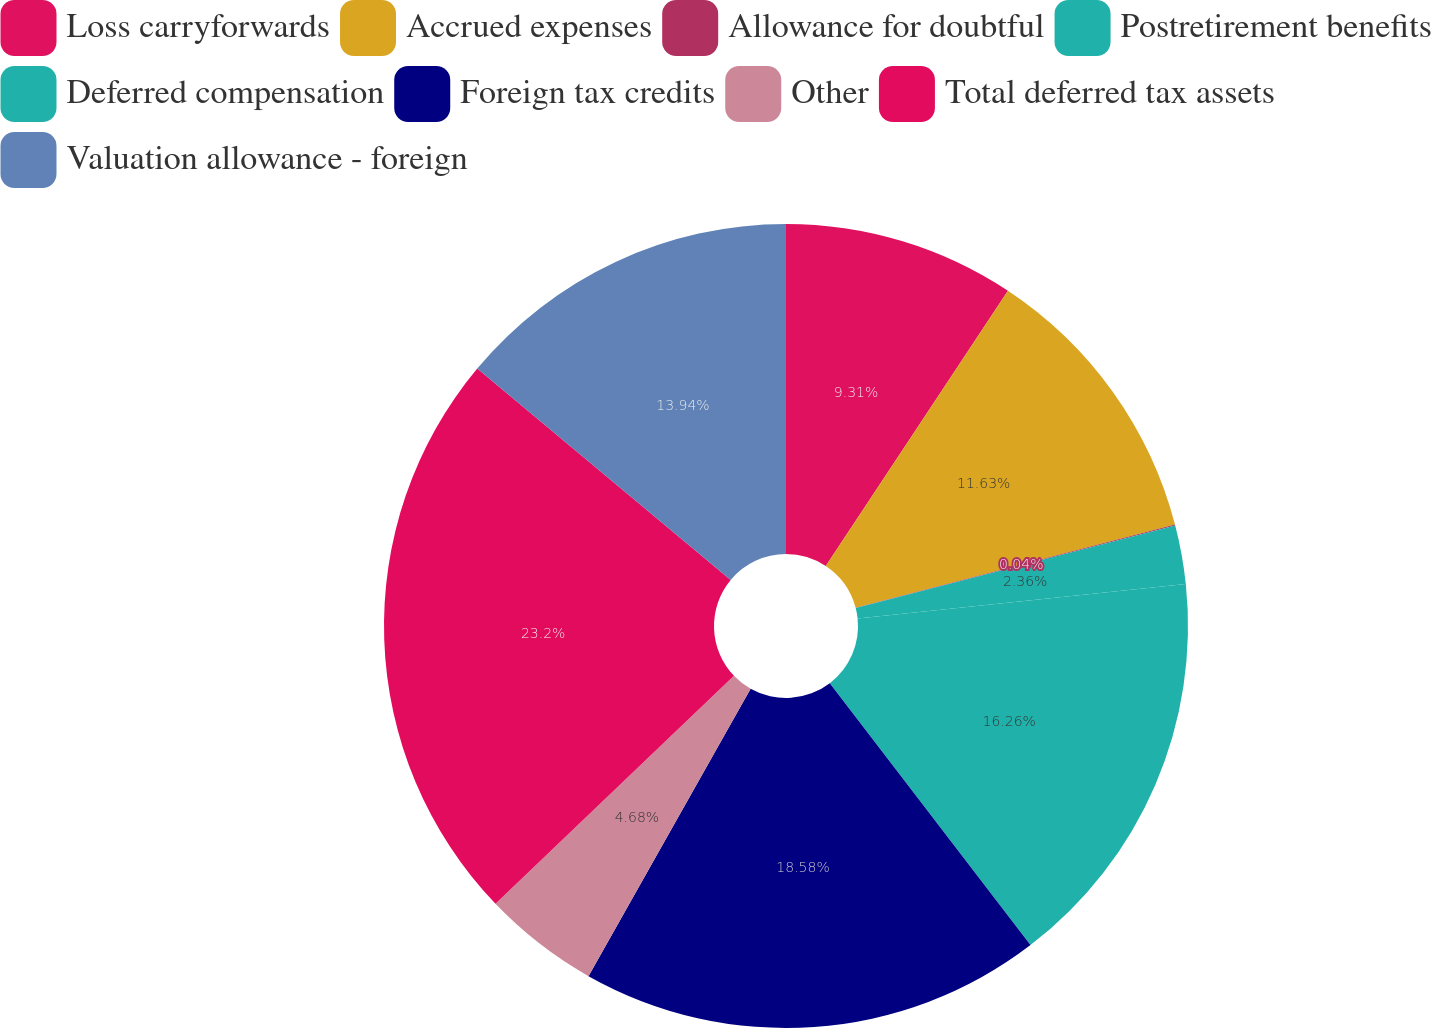Convert chart. <chart><loc_0><loc_0><loc_500><loc_500><pie_chart><fcel>Loss carryforwards<fcel>Accrued expenses<fcel>Allowance for doubtful<fcel>Postretirement benefits<fcel>Deferred compensation<fcel>Foreign tax credits<fcel>Other<fcel>Total deferred tax assets<fcel>Valuation allowance - foreign<nl><fcel>9.31%<fcel>11.63%<fcel>0.04%<fcel>2.36%<fcel>16.26%<fcel>18.58%<fcel>4.68%<fcel>23.21%<fcel>13.94%<nl></chart> 